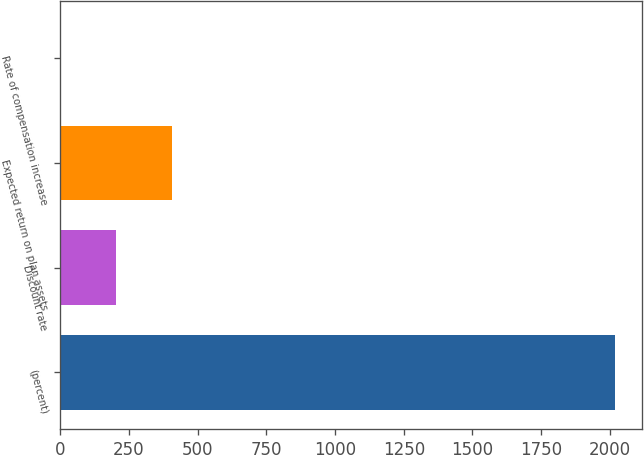Convert chart to OTSL. <chart><loc_0><loc_0><loc_500><loc_500><bar_chart><fcel>(percent)<fcel>Discount rate<fcel>Expected return on plan assets<fcel>Rate of compensation increase<nl><fcel>2017<fcel>204.4<fcel>405.8<fcel>3<nl></chart> 